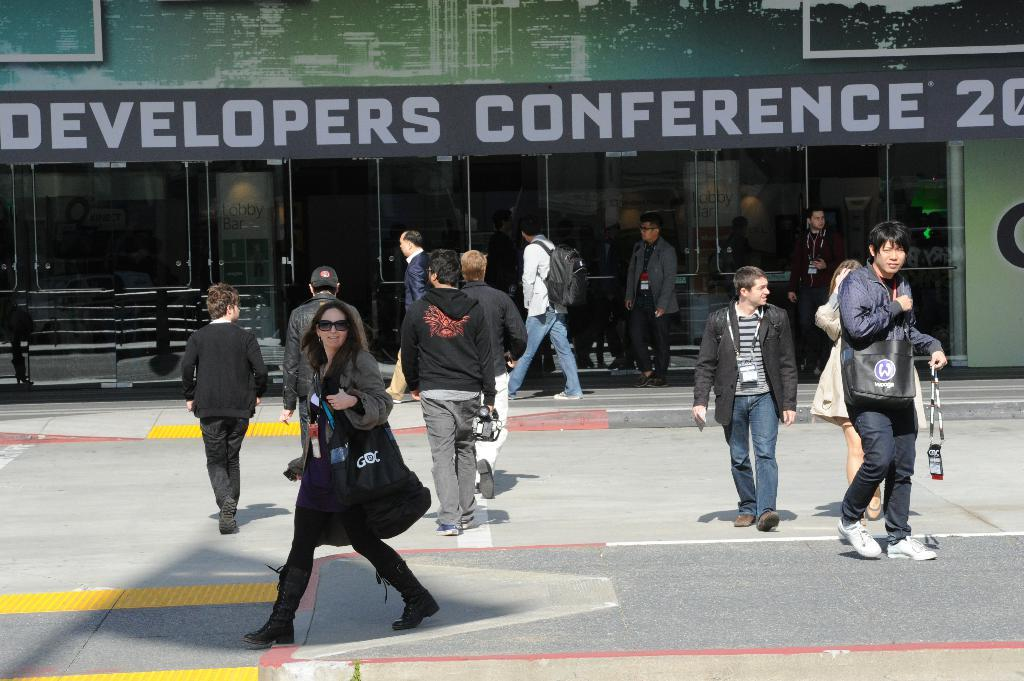What are the people in the image doing? The people in the image are walking on the road. What can be seen in the background of the image? There is a building in the background of the image. What is written on the building? There is text written on the building. What type of wheel is visible on the sidewalk in the image? There is no wheel visible on the sidewalk in the image. At what angle is the building leaning in the image? The building is not leaning in the image; it is standing upright. 